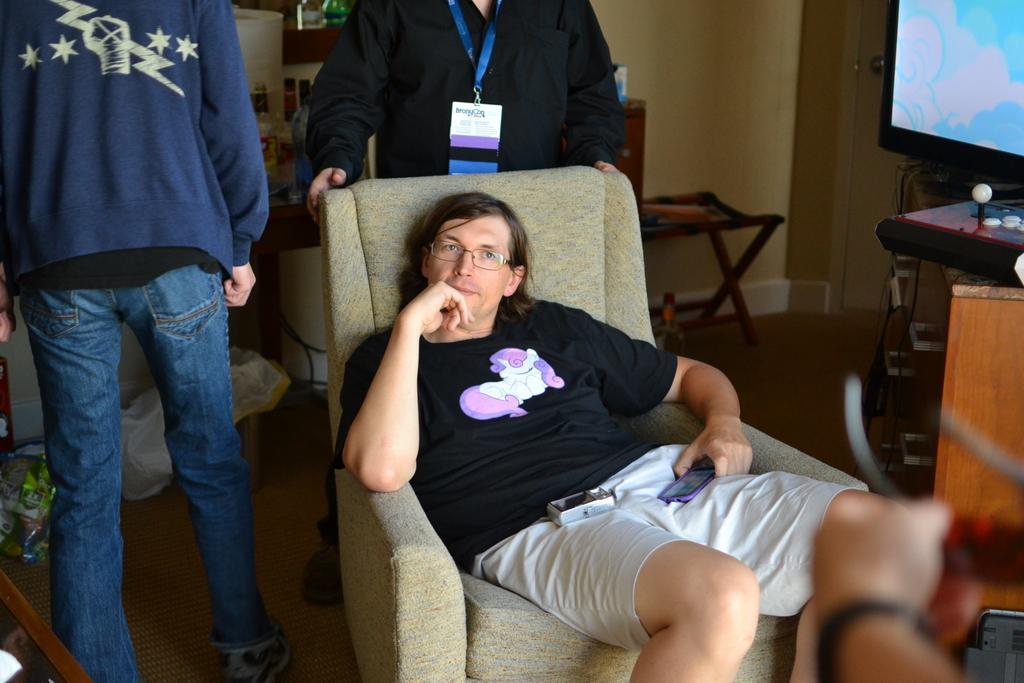Describe this image in one or two sentences. In this image i can see a man sitting on the couch, In the background i can see 2 other person standing , the wall , a television screen and the joy stick. 